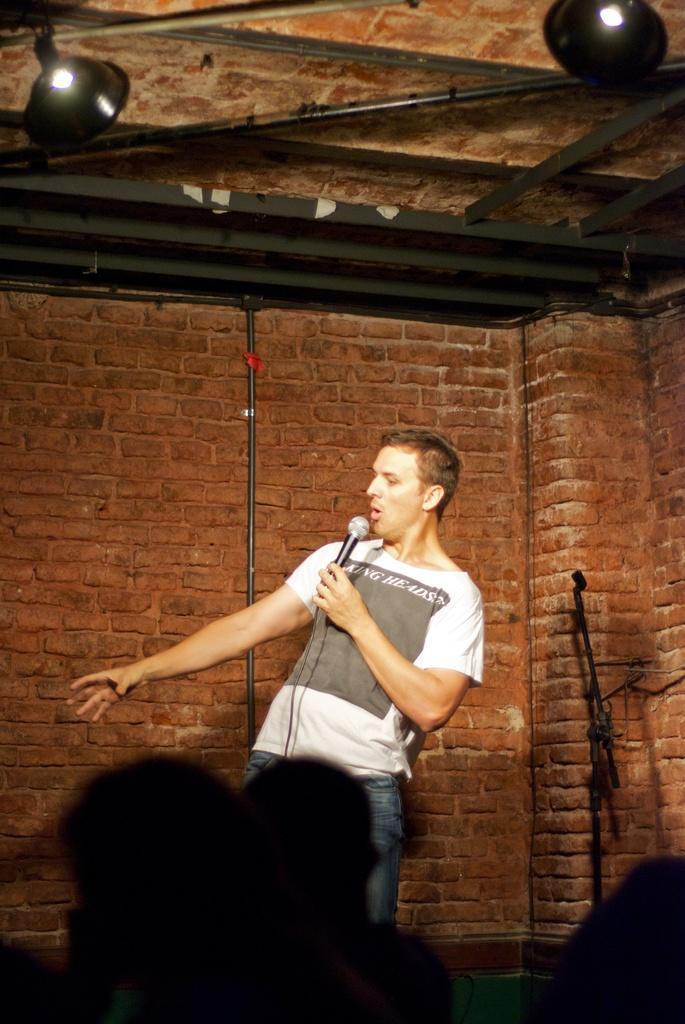Describe this image in one or two sentences. In the center of the picture there is a person holding a mic. In the background there is a brick wall. On the right there is a stand. In the foreground it is blurred. 